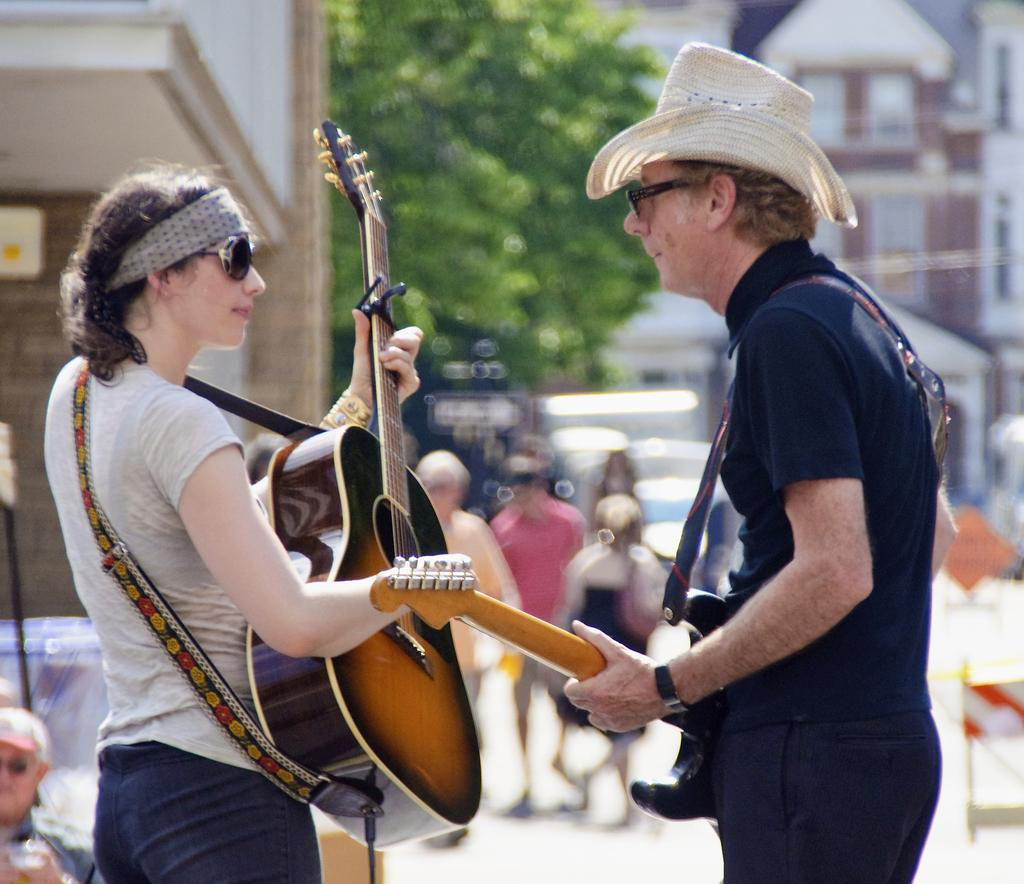What are the men and women in the image holding? The men and women in the image are holding guitars. What are the men and women doing with the guitars? The men and women are standing and holding guitars, which suggests they might be playing or posing with them. What can be seen in the background of the image? There is a tree and buildings in the background of the image. Are there any other people visible in the image? Yes, there are people in the background of the image. What type of feast is being prepared by the woman in the image? There is no woman or feast present in the image; it features men and women holding guitars. Can you tell me how many wounds are visible on the men and women in the image? There are no visible wounds on the men and women in the image. 